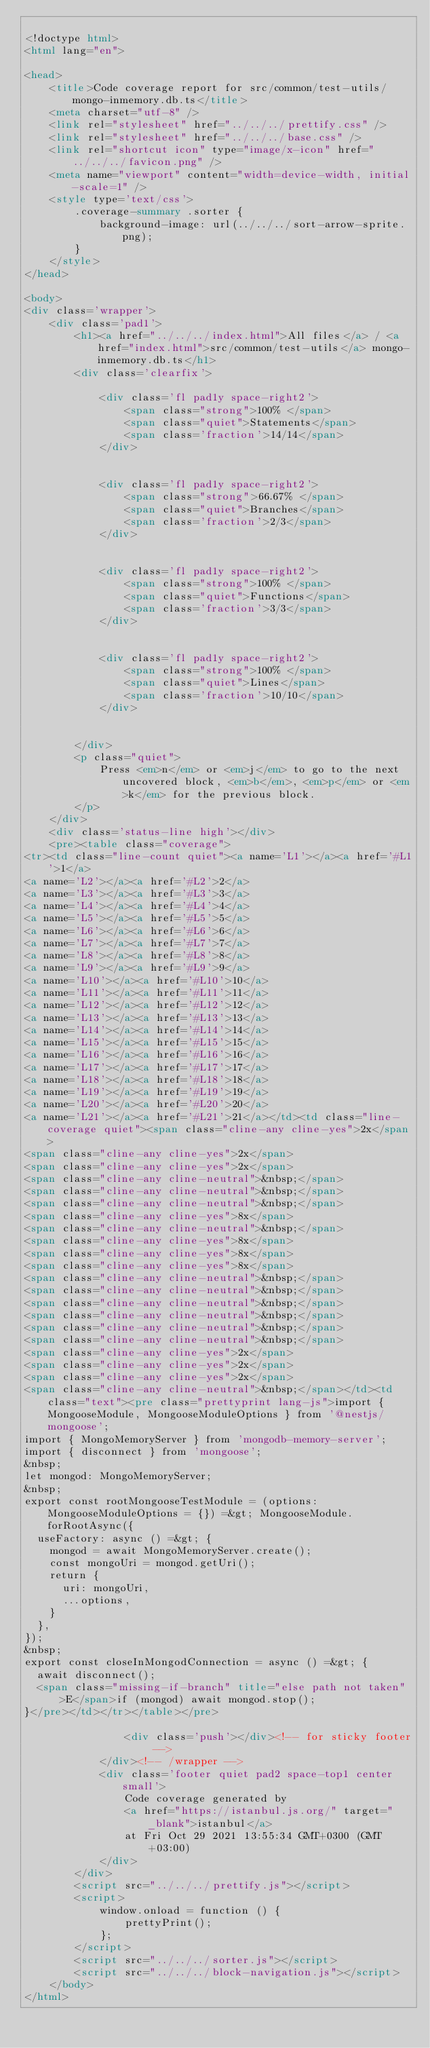<code> <loc_0><loc_0><loc_500><loc_500><_HTML_>
<!doctype html>
<html lang="en">

<head>
    <title>Code coverage report for src/common/test-utils/mongo-inmemory.db.ts</title>
    <meta charset="utf-8" />
    <link rel="stylesheet" href="../../../prettify.css" />
    <link rel="stylesheet" href="../../../base.css" />
    <link rel="shortcut icon" type="image/x-icon" href="../../../favicon.png" />
    <meta name="viewport" content="width=device-width, initial-scale=1" />
    <style type='text/css'>
        .coverage-summary .sorter {
            background-image: url(../../../sort-arrow-sprite.png);
        }
    </style>
</head>
    
<body>
<div class='wrapper'>
    <div class='pad1'>
        <h1><a href="../../../index.html">All files</a> / <a href="index.html">src/common/test-utils</a> mongo-inmemory.db.ts</h1>
        <div class='clearfix'>
            
            <div class='fl pad1y space-right2'>
                <span class="strong">100% </span>
                <span class="quiet">Statements</span>
                <span class='fraction'>14/14</span>
            </div>
        
            
            <div class='fl pad1y space-right2'>
                <span class="strong">66.67% </span>
                <span class="quiet">Branches</span>
                <span class='fraction'>2/3</span>
            </div>
        
            
            <div class='fl pad1y space-right2'>
                <span class="strong">100% </span>
                <span class="quiet">Functions</span>
                <span class='fraction'>3/3</span>
            </div>
        
            
            <div class='fl pad1y space-right2'>
                <span class="strong">100% </span>
                <span class="quiet">Lines</span>
                <span class='fraction'>10/10</span>
            </div>
        
            
        </div>
        <p class="quiet">
            Press <em>n</em> or <em>j</em> to go to the next uncovered block, <em>b</em>, <em>p</em> or <em>k</em> for the previous block.
        </p>
    </div>
    <div class='status-line high'></div>
    <pre><table class="coverage">
<tr><td class="line-count quiet"><a name='L1'></a><a href='#L1'>1</a>
<a name='L2'></a><a href='#L2'>2</a>
<a name='L3'></a><a href='#L3'>3</a>
<a name='L4'></a><a href='#L4'>4</a>
<a name='L5'></a><a href='#L5'>5</a>
<a name='L6'></a><a href='#L6'>6</a>
<a name='L7'></a><a href='#L7'>7</a>
<a name='L8'></a><a href='#L8'>8</a>
<a name='L9'></a><a href='#L9'>9</a>
<a name='L10'></a><a href='#L10'>10</a>
<a name='L11'></a><a href='#L11'>11</a>
<a name='L12'></a><a href='#L12'>12</a>
<a name='L13'></a><a href='#L13'>13</a>
<a name='L14'></a><a href='#L14'>14</a>
<a name='L15'></a><a href='#L15'>15</a>
<a name='L16'></a><a href='#L16'>16</a>
<a name='L17'></a><a href='#L17'>17</a>
<a name='L18'></a><a href='#L18'>18</a>
<a name='L19'></a><a href='#L19'>19</a>
<a name='L20'></a><a href='#L20'>20</a>
<a name='L21'></a><a href='#L21'>21</a></td><td class="line-coverage quiet"><span class="cline-any cline-yes">2x</span>
<span class="cline-any cline-yes">2x</span>
<span class="cline-any cline-yes">2x</span>
<span class="cline-any cline-neutral">&nbsp;</span>
<span class="cline-any cline-neutral">&nbsp;</span>
<span class="cline-any cline-neutral">&nbsp;</span>
<span class="cline-any cline-yes">8x</span>
<span class="cline-any cline-neutral">&nbsp;</span>
<span class="cline-any cline-yes">8x</span>
<span class="cline-any cline-yes">8x</span>
<span class="cline-any cline-yes">8x</span>
<span class="cline-any cline-neutral">&nbsp;</span>
<span class="cline-any cline-neutral">&nbsp;</span>
<span class="cline-any cline-neutral">&nbsp;</span>
<span class="cline-any cline-neutral">&nbsp;</span>
<span class="cline-any cline-neutral">&nbsp;</span>
<span class="cline-any cline-neutral">&nbsp;</span>
<span class="cline-any cline-yes">2x</span>
<span class="cline-any cline-yes">2x</span>
<span class="cline-any cline-yes">2x</span>
<span class="cline-any cline-neutral">&nbsp;</span></td><td class="text"><pre class="prettyprint lang-js">import { MongooseModule, MongooseModuleOptions } from '@nestjs/mongoose';
import { MongoMemoryServer } from 'mongodb-memory-server';
import { disconnect } from 'mongoose';
&nbsp;
let mongod: MongoMemoryServer;
&nbsp;
export const rootMongooseTestModule = (options: MongooseModuleOptions = {}) =&gt; MongooseModule.forRootAsync({
  useFactory: async () =&gt; {
    mongod = await MongoMemoryServer.create();
    const mongoUri = mongod.getUri();
    return {
      uri: mongoUri,
      ...options,
    }
  },
});
&nbsp;
export const closeInMongodConnection = async () =&gt; {
  await disconnect();
  <span class="missing-if-branch" title="else path not taken" >E</span>if (mongod) await mongod.stop();
}</pre></td></tr></table></pre>

                <div class='push'></div><!-- for sticky footer -->
            </div><!-- /wrapper -->
            <div class='footer quiet pad2 space-top1 center small'>
                Code coverage generated by
                <a href="https://istanbul.js.org/" target="_blank">istanbul</a>
                at Fri Oct 29 2021 13:55:34 GMT+0300 (GMT+03:00)
            </div>
        </div>
        <script src="../../../prettify.js"></script>
        <script>
            window.onload = function () {
                prettyPrint();
            };
        </script>
        <script src="../../../sorter.js"></script>
        <script src="../../../block-navigation.js"></script>
    </body>
</html>
    </code> 